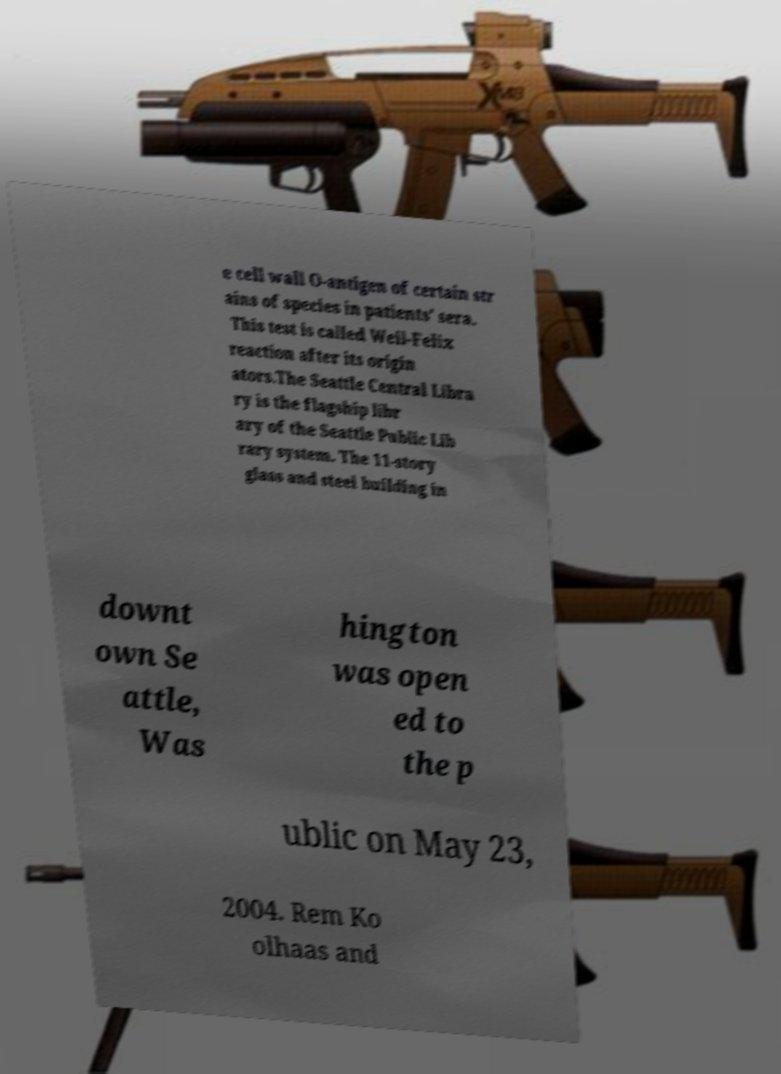What messages or text are displayed in this image? I need them in a readable, typed format. e cell wall O-antigen of certain str ains of species in patients' sera. This test is called Weil-Felix reaction after its origin ators.The Seattle Central Libra ry is the flagship libr ary of the Seattle Public Lib rary system. The 11-story glass and steel building in downt own Se attle, Was hington was open ed to the p ublic on May 23, 2004. Rem Ko olhaas and 